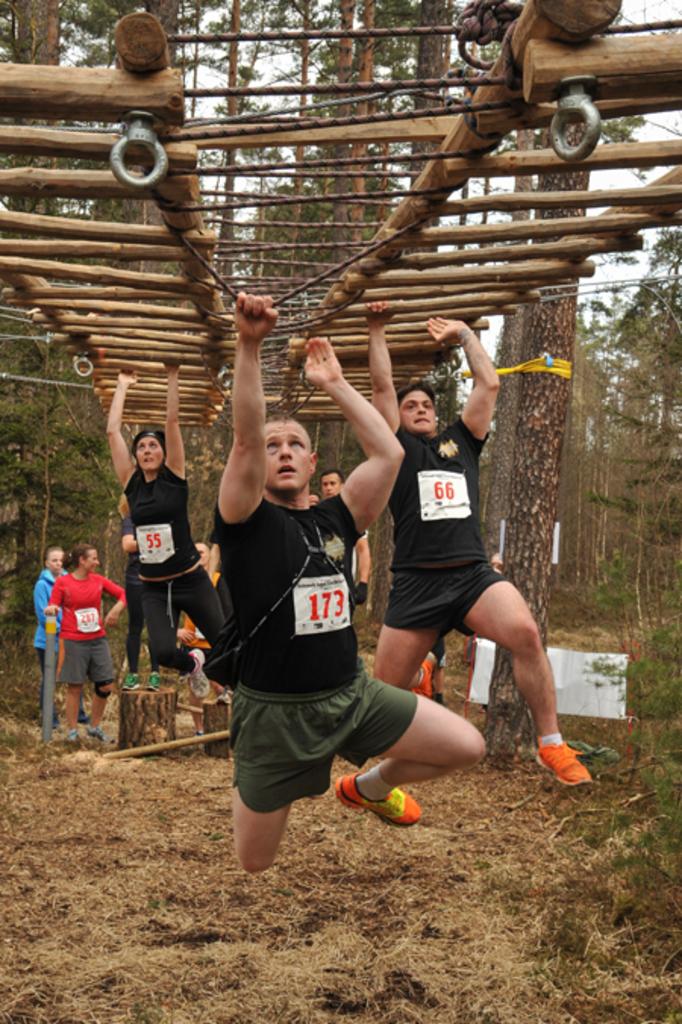What number is the guy in the lead?
Make the answer very short. 173. What is the number of the guy in second place?
Ensure brevity in your answer.  66. 